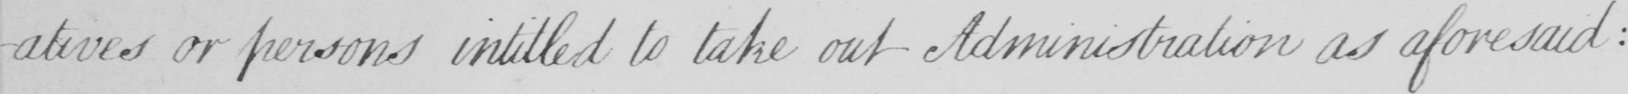Can you tell me what this handwritten text says? or persons intitled to take out Administation as aforesaid : 